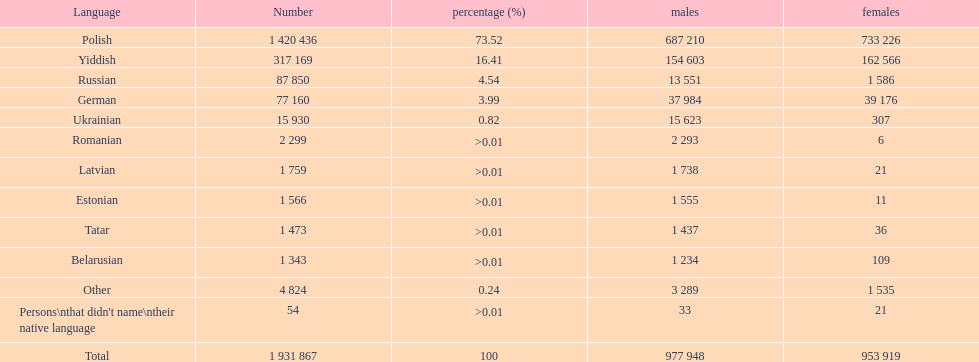What languages are used in the warsaw administrative region? Polish, Yiddish, Russian, German, Ukrainian, Romanian, Latvian, Estonian, Tatar, Belarusian, Other, Persons\nthat didn't name\ntheir native language. What is the figure for russian? 87 850. On this list, what is the next lesser number? 77 160. Which language comprises a count of 77160 speakers? German. 